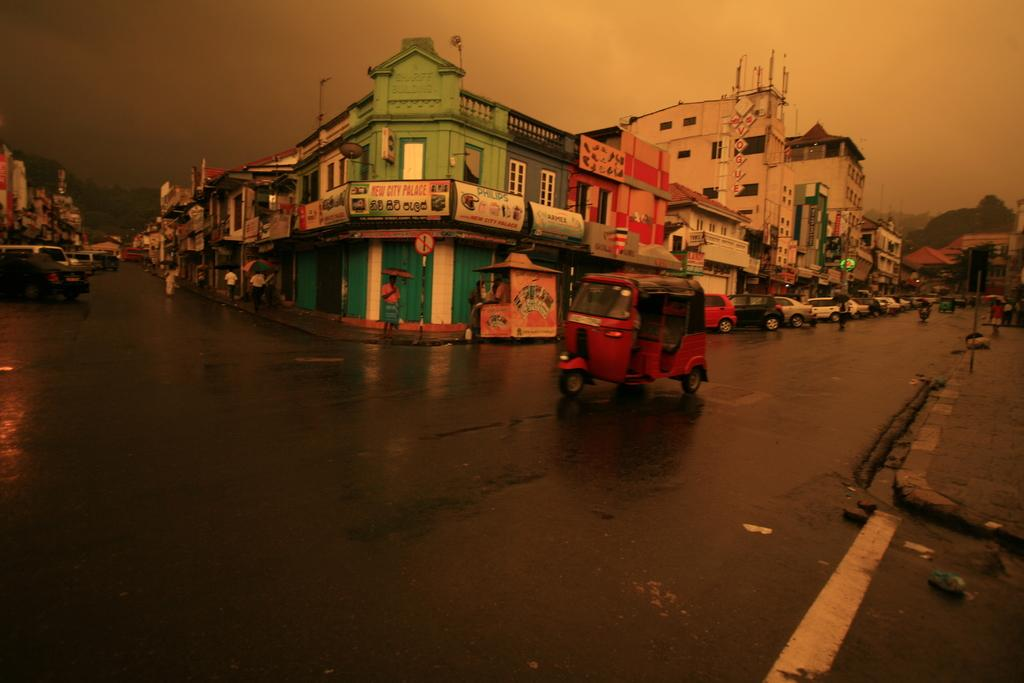What type of structures can be seen in the image? There are buildings in the image. What type of vehicles are on the road in the image? There are cars and an auto rickshaw on the road in the image. What are the people in the image doing? The people are walking in the image. What are the people holding while walking? The people are holding umbrellas. What type of vegetation is present in the image? There are trees in the image. What part of the natural environment is visible in the image? The sky is visible in the image. What type of behavior can be observed in the ring in the image? There is no ring present in the image, so no behavior can be observed in a ring. What day of the week is it in the image? The day of the week is not mentioned or visible in the image. 